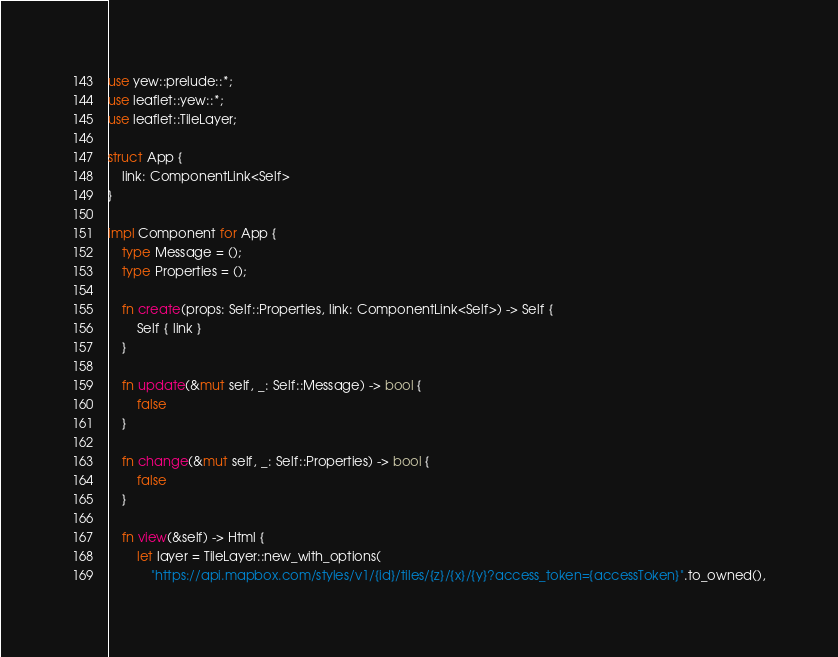Convert code to text. <code><loc_0><loc_0><loc_500><loc_500><_Rust_>use yew::prelude::*;
use leaflet::yew::*;
use leaflet::TileLayer;

struct App {
    link: ComponentLink<Self>
}

impl Component for App {
    type Message = ();
    type Properties = ();

    fn create(props: Self::Properties, link: ComponentLink<Self>) -> Self {
        Self { link }
    }

    fn update(&mut self, _: Self::Message) -> bool {
        false
    }

    fn change(&mut self, _: Self::Properties) -> bool {
        false
    }

    fn view(&self) -> Html {
        let layer = TileLayer::new_with_options(
            "https://api.mapbox.com/styles/v1/{id}/tiles/{z}/{x}/{y}?access_token={accessToken}".to_owned(),</code> 